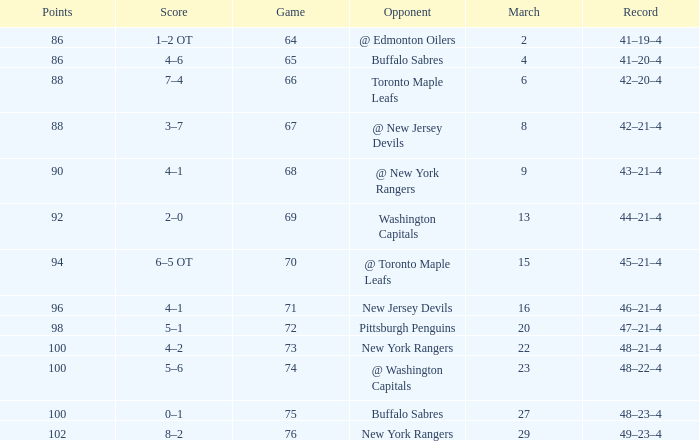Which Opponent has a Record of 45–21–4? @ Toronto Maple Leafs. 